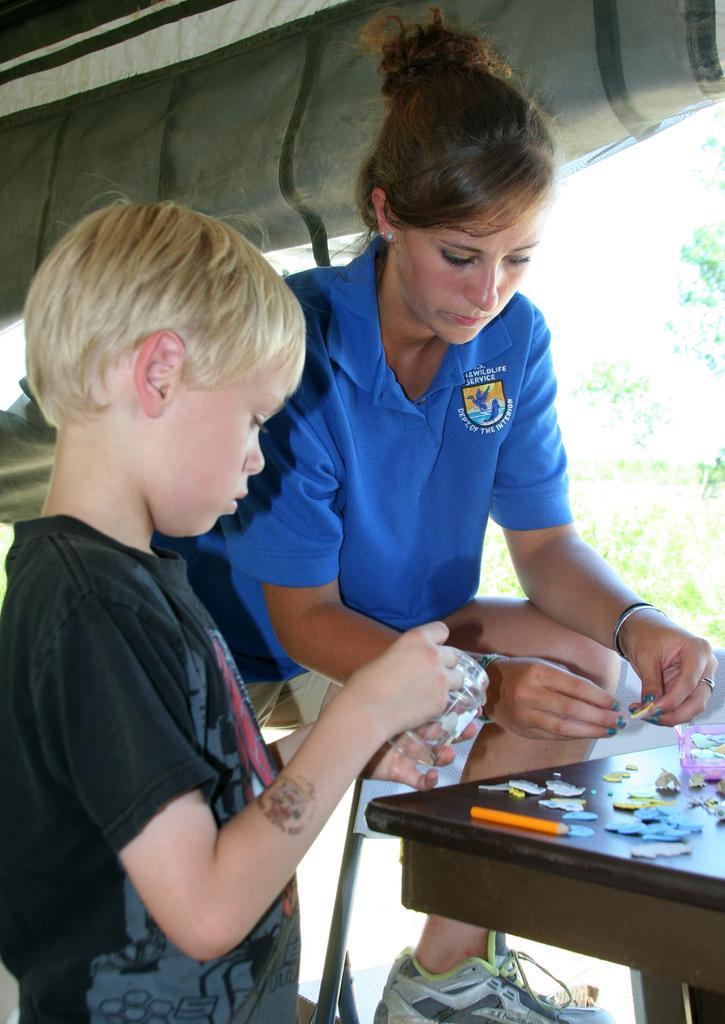Could you give a brief overview of what you see in this image? In the image we can see a woman and a child, wearing clothes. The woman is wearing shoes, bracelet, finger ring and ear studs. Here we can see a wooden table and things on the table. Here we can see a tree and the tent. 